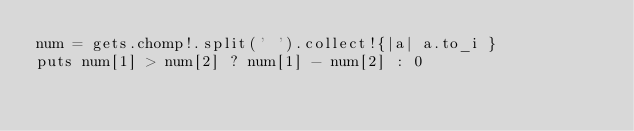<code> <loc_0><loc_0><loc_500><loc_500><_Ruby_>num = gets.chomp!.split(' ').collect!{|a| a.to_i }
puts num[1] > num[2] ? num[1] - num[2] : 0</code> 